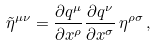Convert formula to latex. <formula><loc_0><loc_0><loc_500><loc_500>\tilde { \eta } ^ { \mu \nu } = \frac { \partial q ^ { \mu } } { \partial x ^ { \rho } } \frac { \partial q ^ { \nu } } { \partial x ^ { \sigma } } \, \eta ^ { \rho \sigma } \, ,</formula> 